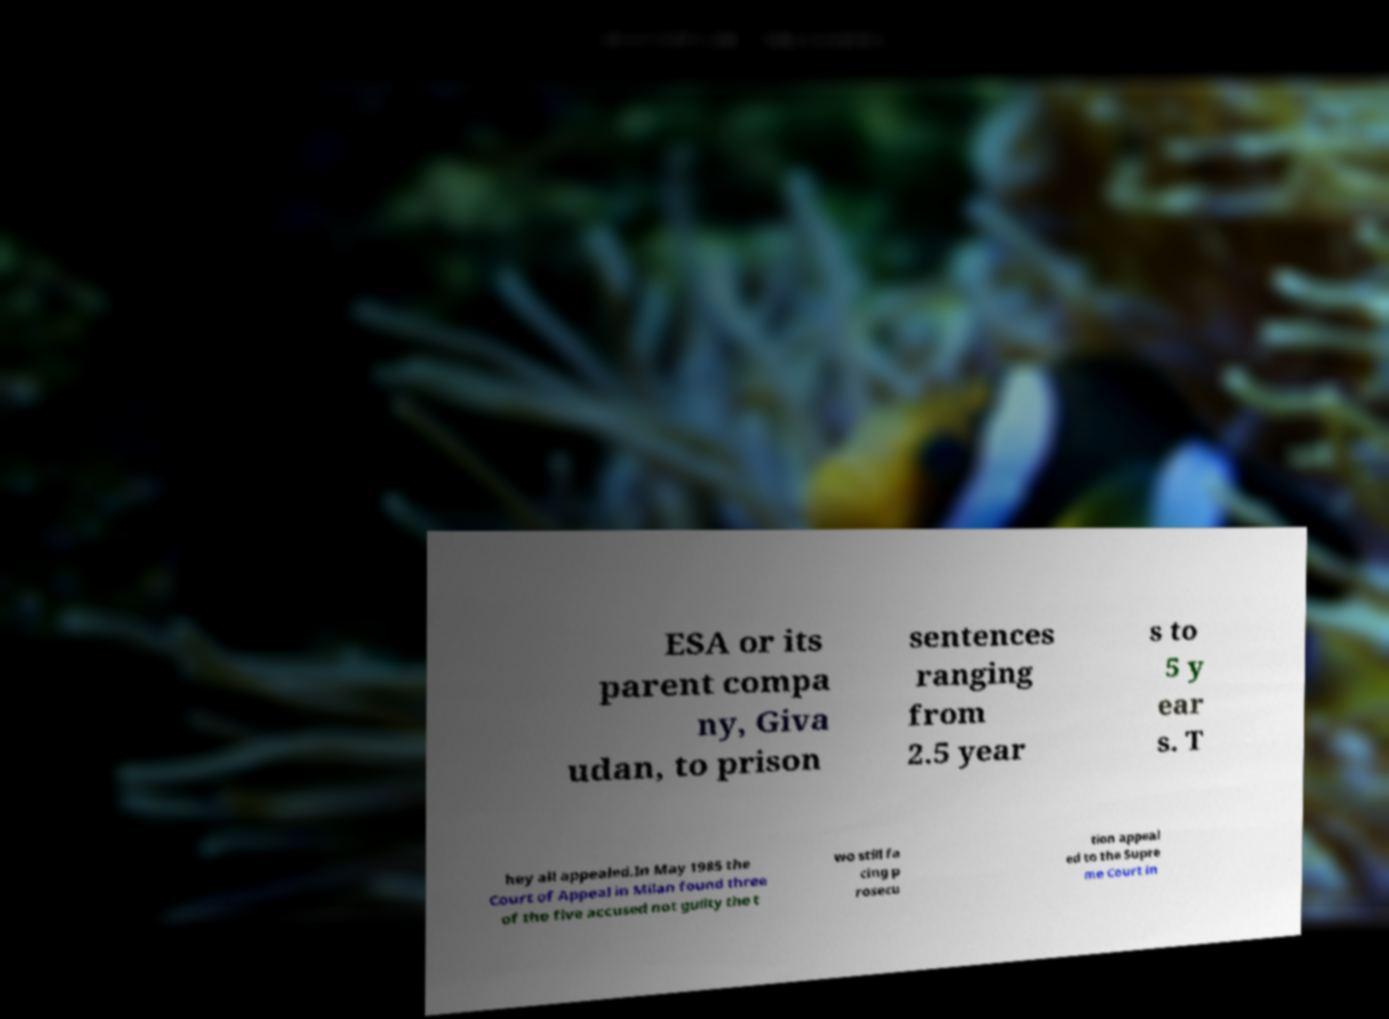There's text embedded in this image that I need extracted. Can you transcribe it verbatim? ESA or its parent compa ny, Giva udan, to prison sentences ranging from 2.5 year s to 5 y ear s. T hey all appealed.In May 1985 the Court of Appeal in Milan found three of the five accused not guilty the t wo still fa cing p rosecu tion appeal ed to the Supre me Court in 